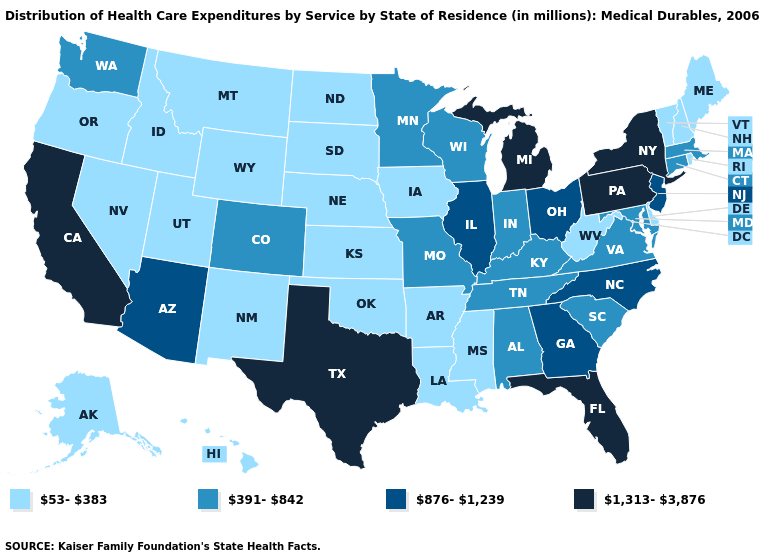What is the lowest value in the South?
Concise answer only. 53-383. What is the lowest value in the Northeast?
Keep it brief. 53-383. Among the states that border New Hampshire , which have the lowest value?
Concise answer only. Maine, Vermont. Name the states that have a value in the range 1,313-3,876?
Keep it brief. California, Florida, Michigan, New York, Pennsylvania, Texas. How many symbols are there in the legend?
Write a very short answer. 4. Among the states that border South Dakota , does Minnesota have the highest value?
Short answer required. Yes. What is the value of Georgia?
Be succinct. 876-1,239. What is the highest value in the USA?
Short answer required. 1,313-3,876. Does Mississippi have a lower value than Colorado?
Write a very short answer. Yes. Name the states that have a value in the range 876-1,239?
Short answer required. Arizona, Georgia, Illinois, New Jersey, North Carolina, Ohio. What is the value of New York?
Quick response, please. 1,313-3,876. Name the states that have a value in the range 1,313-3,876?
Answer briefly. California, Florida, Michigan, New York, Pennsylvania, Texas. What is the lowest value in the South?
Give a very brief answer. 53-383. Which states have the lowest value in the USA?
Keep it brief. Alaska, Arkansas, Delaware, Hawaii, Idaho, Iowa, Kansas, Louisiana, Maine, Mississippi, Montana, Nebraska, Nevada, New Hampshire, New Mexico, North Dakota, Oklahoma, Oregon, Rhode Island, South Dakota, Utah, Vermont, West Virginia, Wyoming. Does the map have missing data?
Give a very brief answer. No. 